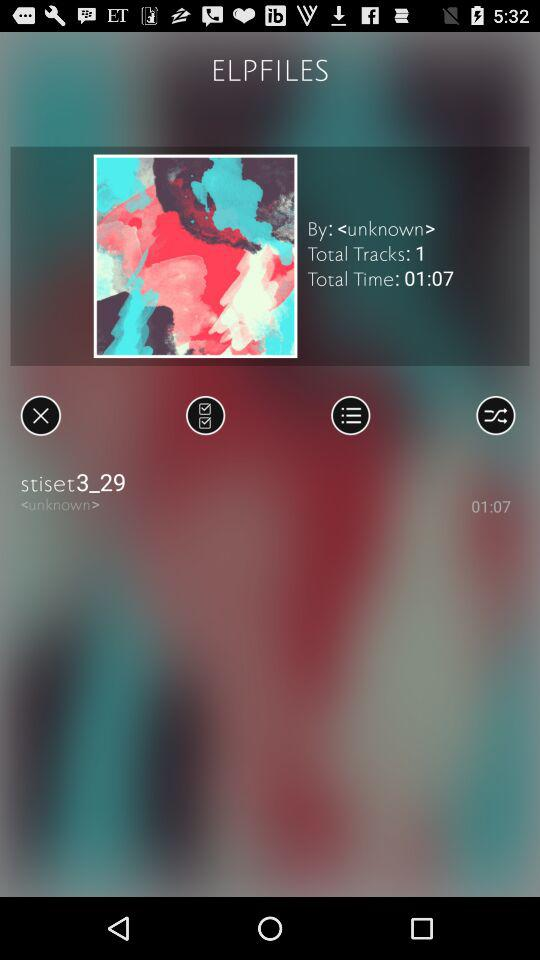What's the total number of tracks? The total number of tracks is 1. 